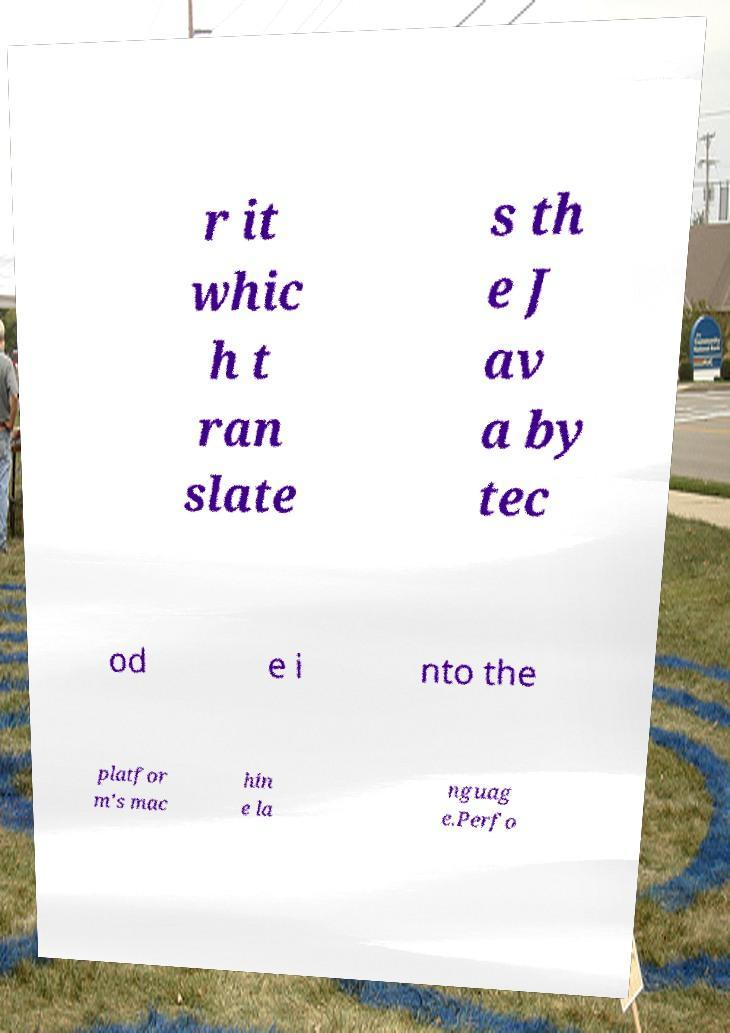There's text embedded in this image that I need extracted. Can you transcribe it verbatim? r it whic h t ran slate s th e J av a by tec od e i nto the platfor m's mac hin e la nguag e.Perfo 